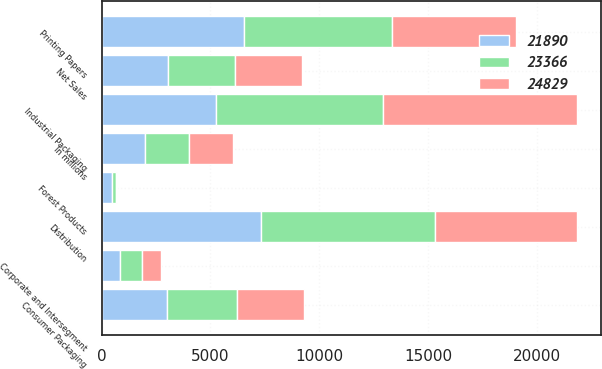Convert chart. <chart><loc_0><loc_0><loc_500><loc_500><stacked_bar_chart><ecel><fcel>In millions<fcel>Industrial Packaging<fcel>Printing Papers<fcel>Consumer Packaging<fcel>Distribution<fcel>Forest Products<fcel>Corporate and Intersegment<fcel>Net Sales<nl><fcel>24829<fcel>2009<fcel>8890<fcel>5680<fcel>3060<fcel>6525<fcel>45<fcel>834<fcel>3060<nl><fcel>23366<fcel>2008<fcel>7690<fcel>6810<fcel>3195<fcel>7970<fcel>200<fcel>1036<fcel>3060<nl><fcel>21890<fcel>2007<fcel>5245<fcel>6530<fcel>3015<fcel>7320<fcel>485<fcel>840<fcel>3060<nl></chart> 